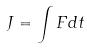Convert formula to latex. <formula><loc_0><loc_0><loc_500><loc_500>J = \int F d t</formula> 